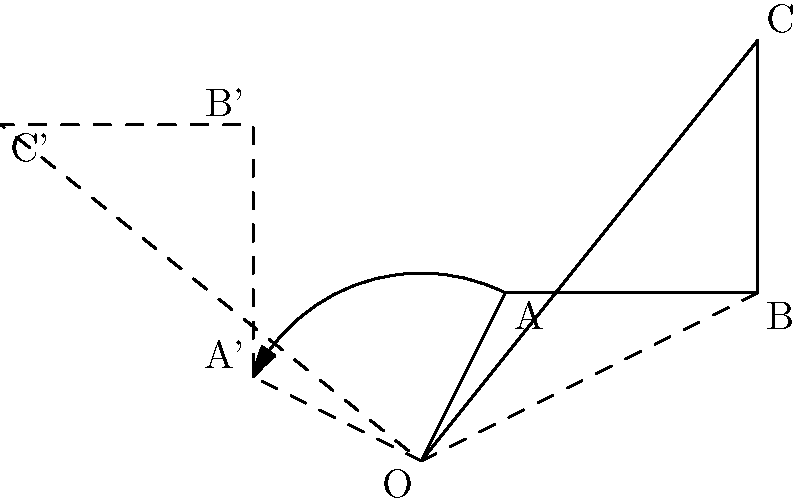As part of an educational initiative to enhance spatial reasoning skills across all student groups, you're designing a geometry lesson. Consider triangle ABC with vertices A(1,2), B(4,2), and C(4,5). If this triangle is rotated 90° counterclockwise around the origin O(0,0), what are the coordinates of vertex C after the rotation? To solve this problem, we'll follow these steps:

1) The general formula for rotating a point $(x,y)$ by $\theta$ degrees counterclockwise around the origin is:
   $$(x',y') = (x\cos\theta - y\sin\theta, x\sin\theta + y\cos\theta)$$

2) In this case, $\theta = 90°$. We know that $\cos 90° = 0$ and $\sin 90° = 1$.

3) The coordinates of point C before rotation are (4,5).

4) Let's apply the rotation formula:
   $$x' = x\cos 90° - y\sin 90° = 4(0) - 5(1) = -5$$
   $$y' = x\sin 90° + y\cos 90° = 4(1) + 5(0) = 4$$

5) Therefore, after rotation, the coordinates of C' are (-5,4).

This rotation demonstrates how geometric transformations can be used to develop spatial reasoning skills, an important aspect of providing equal educational opportunities in mathematics for all students.
Answer: $(-5,4)$ 